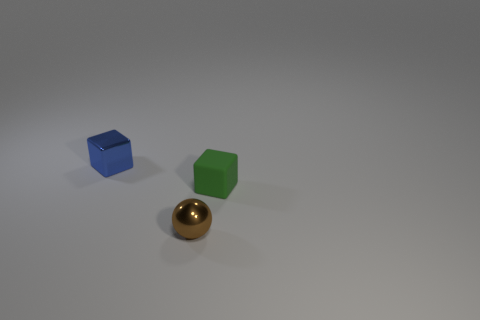There is a object that is behind the small brown shiny ball and on the right side of the blue metallic cube; what size is it?
Your answer should be compact. Small. There is another object that is the same shape as the small green object; what color is it?
Provide a short and direct response. Blue. What is the color of the tiny block that is on the right side of the shiny object that is in front of the small green object?
Make the answer very short. Green. What is the shape of the blue thing?
Offer a very short reply. Cube. What shape is the object that is both on the left side of the small green thing and behind the ball?
Provide a succinct answer. Cube. The small cube that is made of the same material as the small brown object is what color?
Your answer should be very brief. Blue. The metal thing to the right of the tiny shiny thing that is to the left of the metal object in front of the tiny green block is what shape?
Your response must be concise. Sphere. The green rubber block has what size?
Provide a succinct answer. Small. The object that is the same material as the ball is what shape?
Give a very brief answer. Cube. Is the number of cubes that are behind the green cube less than the number of red shiny balls?
Your response must be concise. No. 